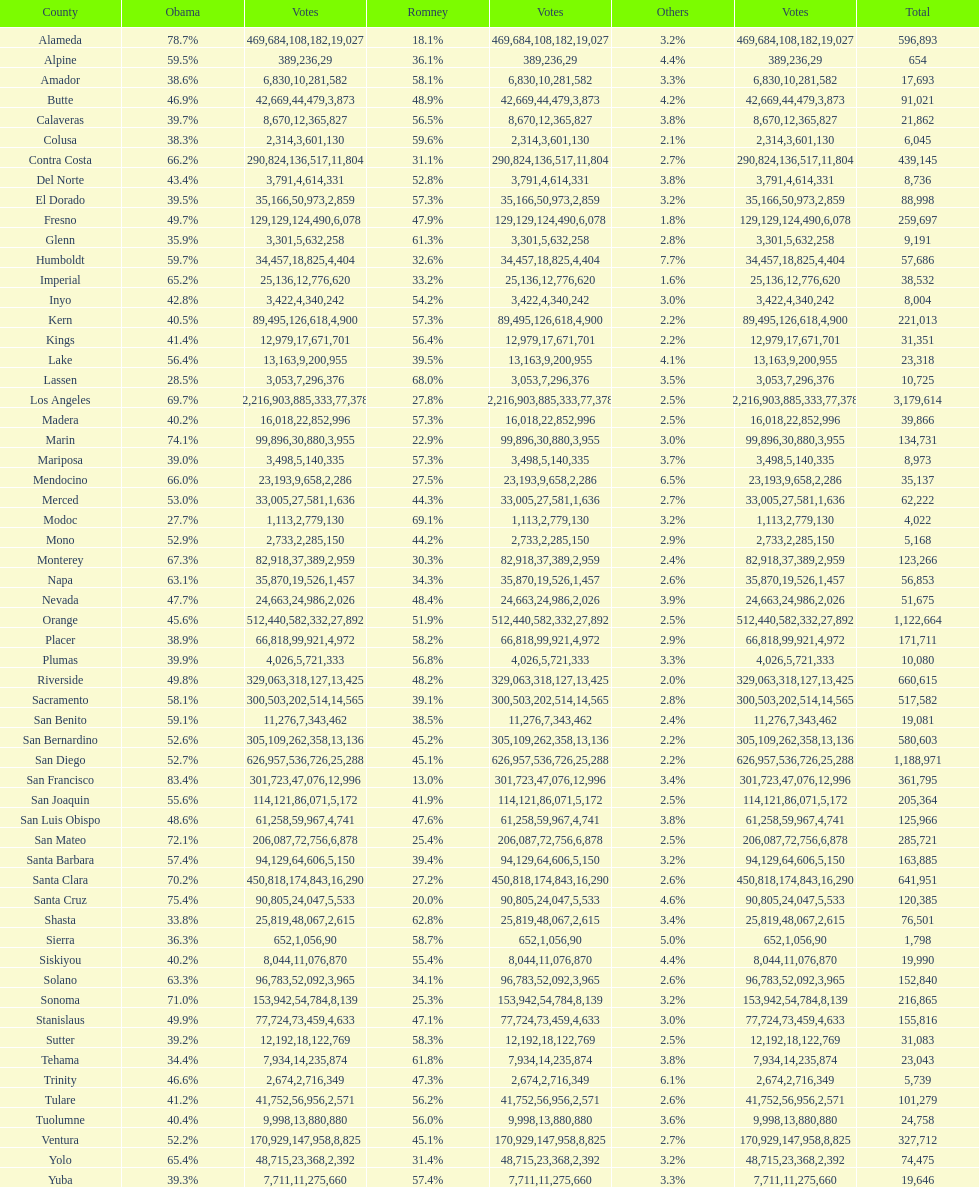Which county had the lower percentage votes for obama: amador, humboldt, or lake? Amador. 